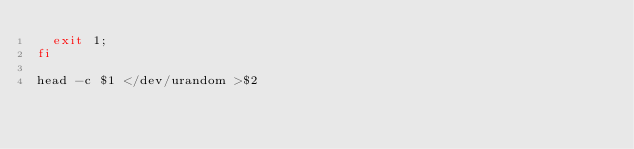<code> <loc_0><loc_0><loc_500><loc_500><_Bash_>  exit 1;
fi

head -c $1 </dev/urandom >$2

</code> 